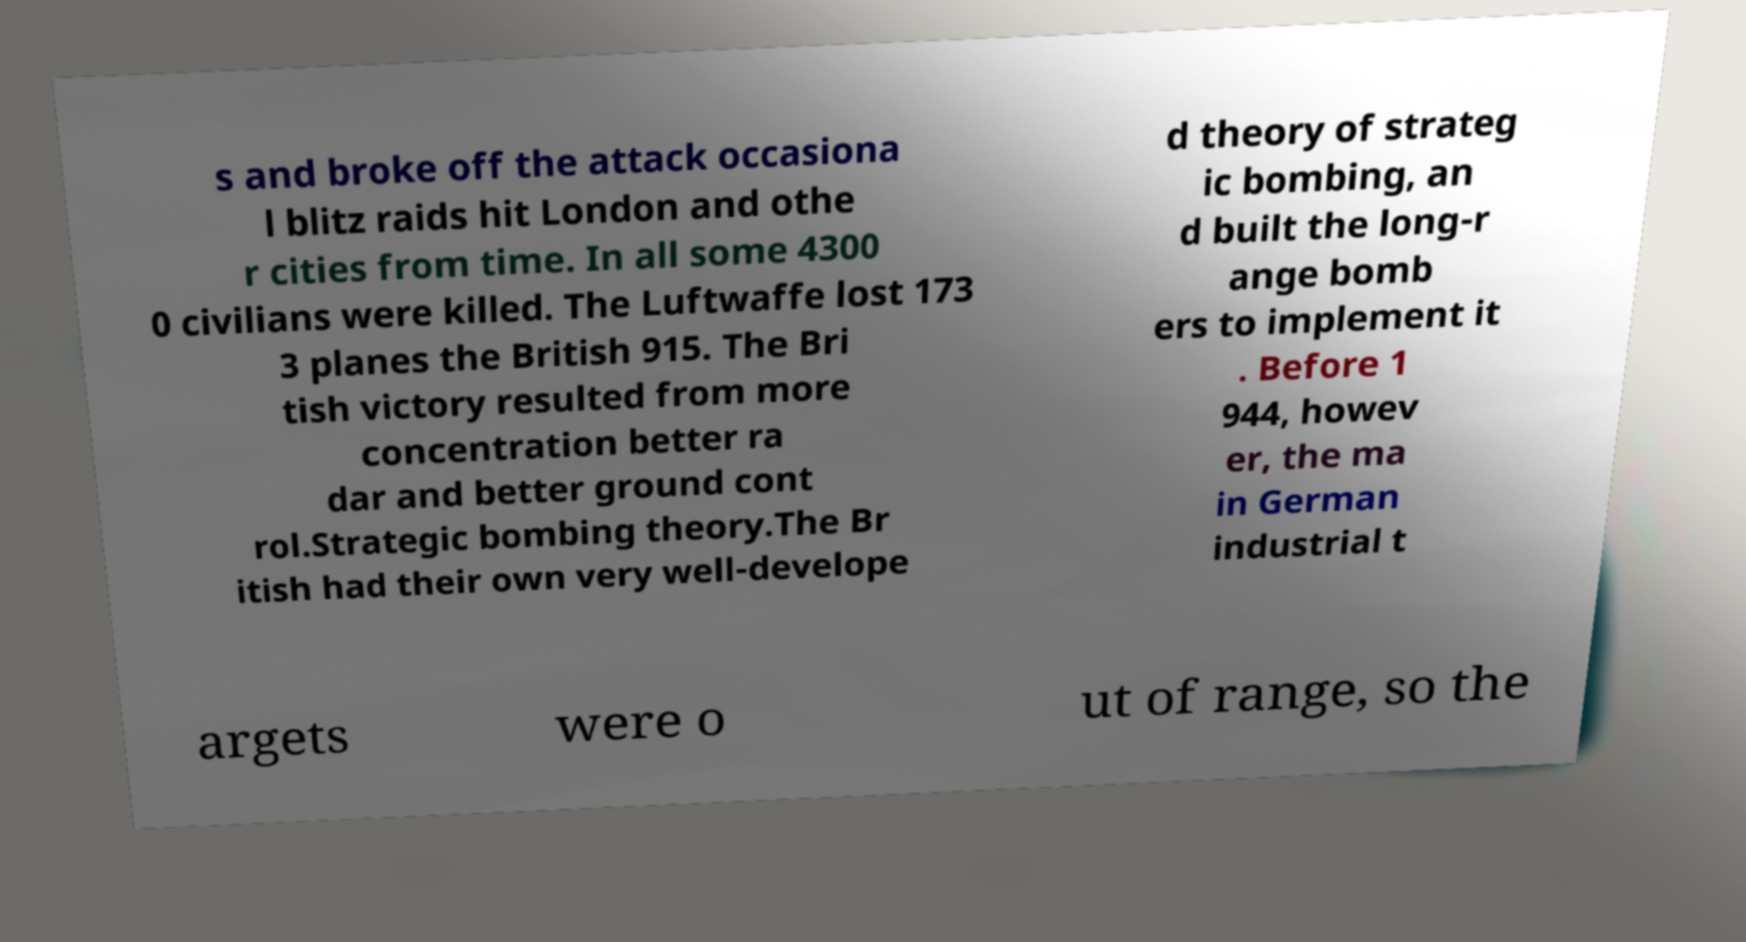There's text embedded in this image that I need extracted. Can you transcribe it verbatim? s and broke off the attack occasiona l blitz raids hit London and othe r cities from time. In all some 4300 0 civilians were killed. The Luftwaffe lost 173 3 planes the British 915. The Bri tish victory resulted from more concentration better ra dar and better ground cont rol.Strategic bombing theory.The Br itish had their own very well-develope d theory of strateg ic bombing, an d built the long-r ange bomb ers to implement it . Before 1 944, howev er, the ma in German industrial t argets were o ut of range, so the 